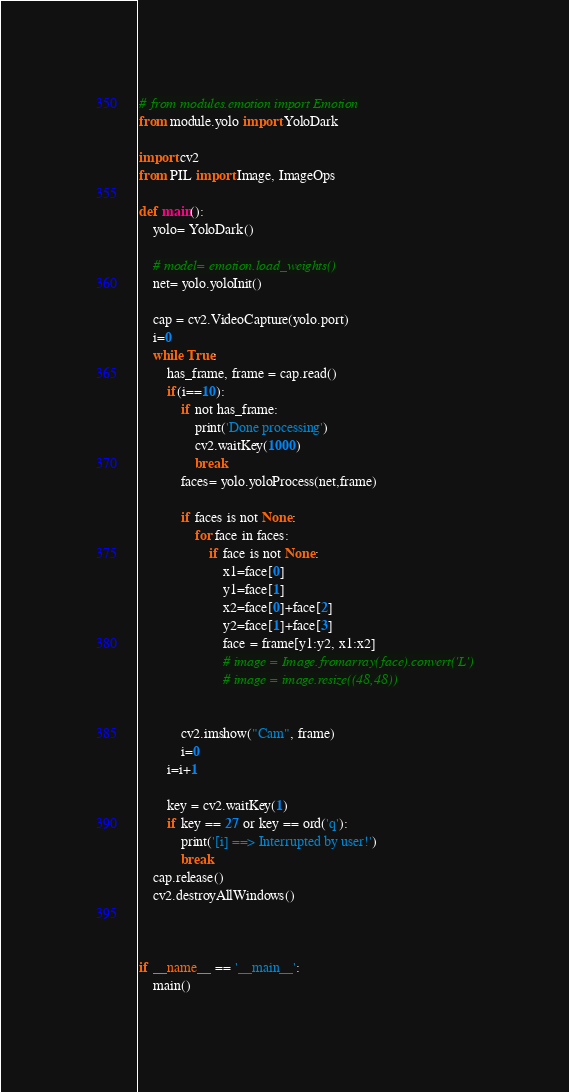Convert code to text. <code><loc_0><loc_0><loc_500><loc_500><_Python_># from modules.emotion import Emotion
from module.yolo import YoloDark

import cv2
from PIL import Image, ImageOps

def main():
    yolo= YoloDark()

    # model= emotion.load_weights()
    net= yolo.yoloInit()

    cap = cv2.VideoCapture(yolo.port)
    i=0
    while True:
        has_frame, frame = cap.read()
        if(i==10):
            if not has_frame:
                print('Done processing')
                cv2.waitKey(1000)
                break
            faces= yolo.yoloProcess(net,frame)

            if faces is not None:
                for face in faces:
                    if face is not None:
                        x1=face[0]
                        y1=face[1]
                        x2=face[0]+face[2]
                        y2=face[1]+face[3]
                        face = frame[y1:y2, x1:x2]
                        # image = Image.fromarray(face).convert('L')
                        # image = image.resize((48,48))


            cv2.imshow("Cam", frame)
            i=0
        i=i+1

        key = cv2.waitKey(1)
        if key == 27 or key == ord('q'):
            print('[i] ==> Interrupted by user!')
            break
    cap.release()
    cv2.destroyAllWindows()



if __name__ == '__main__':
    main()
</code> 